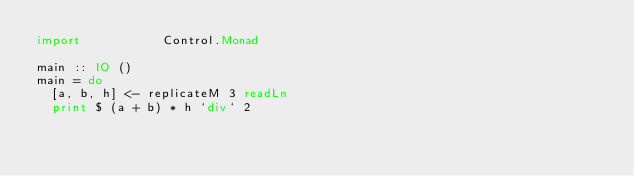<code> <loc_0><loc_0><loc_500><loc_500><_Haskell_>import           Control.Monad

main :: IO ()
main = do
  [a, b, h] <- replicateM 3 readLn
  print $ (a + b) * h `div` 2
</code> 